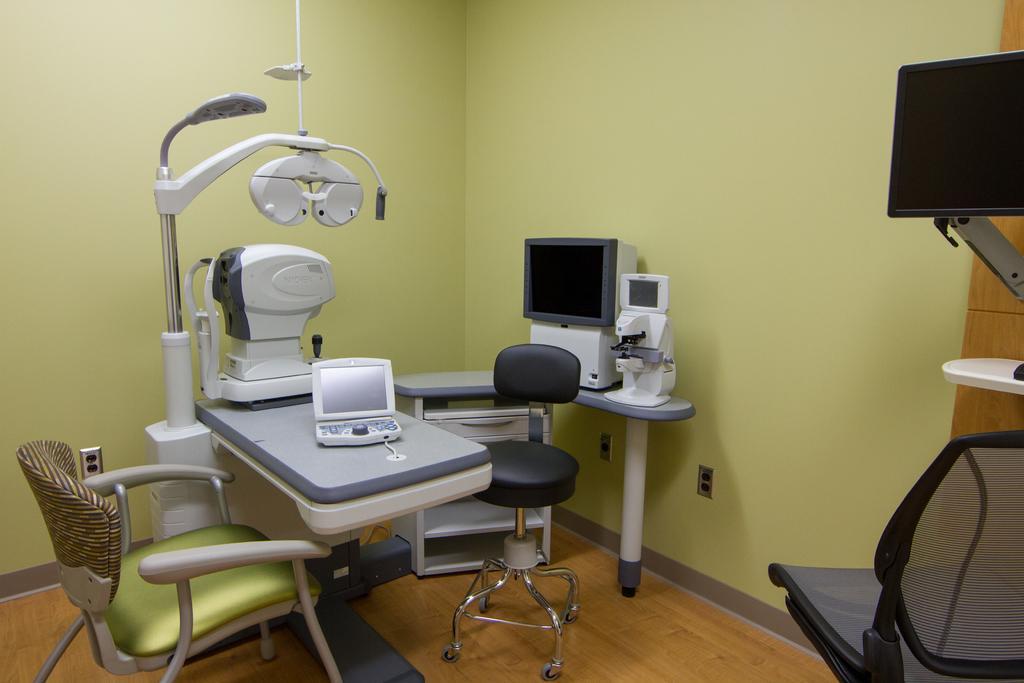In one or two sentences, can you explain what this image depicts? In this image we can see the inner view of a room. In the room there are computers, chairs, side tables and machines. In the background we can see walls. 